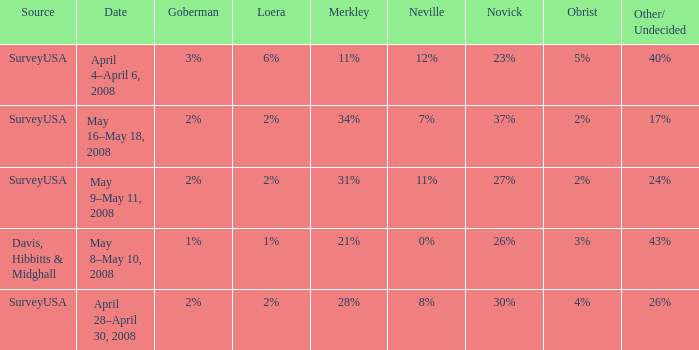Which Date has a Novick of 26%? May 8–May 10, 2008. 